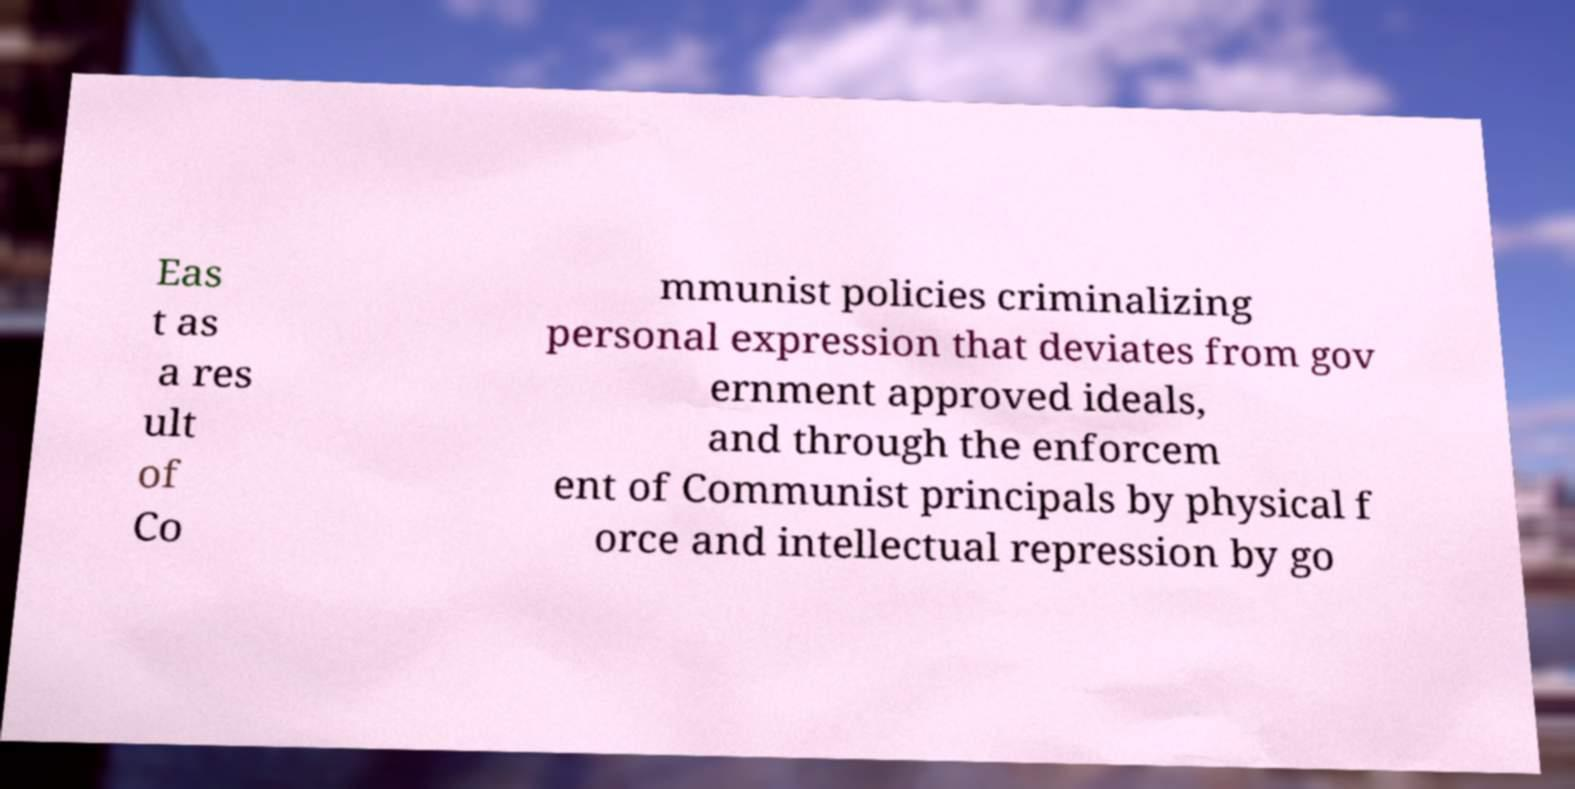Could you extract and type out the text from this image? Eas t as a res ult of Co mmunist policies criminalizing personal expression that deviates from gov ernment approved ideals, and through the enforcem ent of Communist principals by physical f orce and intellectual repression by go 